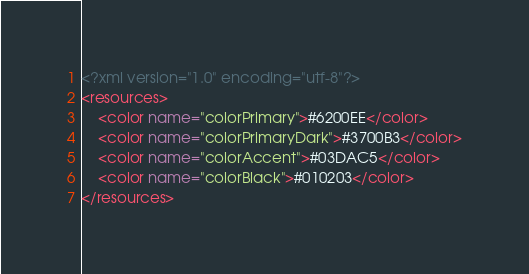Convert code to text. <code><loc_0><loc_0><loc_500><loc_500><_XML_><?xml version="1.0" encoding="utf-8"?>
<resources>
    <color name="colorPrimary">#6200EE</color>
    <color name="colorPrimaryDark">#3700B3</color>
    <color name="colorAccent">#03DAC5</color>
    <color name="colorBlack">#010203</color>
</resources>
</code> 